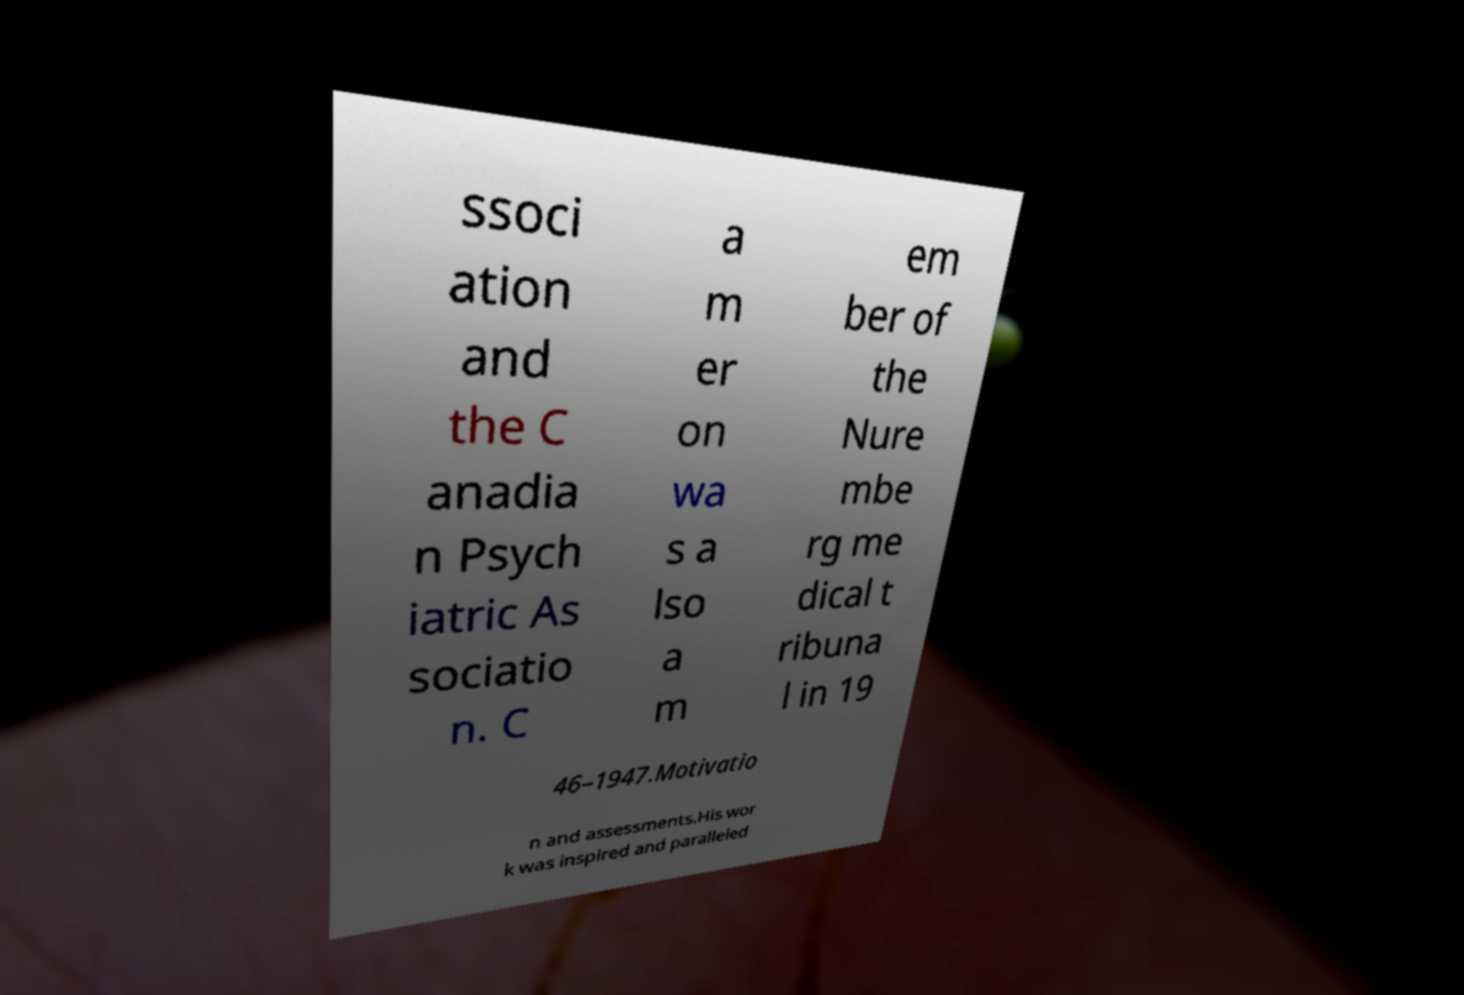Can you read and provide the text displayed in the image?This photo seems to have some interesting text. Can you extract and type it out for me? ssoci ation and the C anadia n Psych iatric As sociatio n. C a m er on wa s a lso a m em ber of the Nure mbe rg me dical t ribuna l in 19 46–1947.Motivatio n and assessments.His wor k was inspired and paralleled 